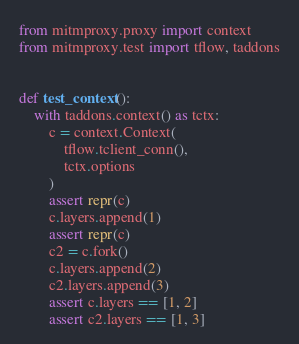<code> <loc_0><loc_0><loc_500><loc_500><_Python_>from mitmproxy.proxy import context
from mitmproxy.test import tflow, taddons


def test_context():
    with taddons.context() as tctx:
        c = context.Context(
            tflow.tclient_conn(),
            tctx.options
        )
        assert repr(c)
        c.layers.append(1)
        assert repr(c)
        c2 = c.fork()
        c.layers.append(2)
        c2.layers.append(3)
        assert c.layers == [1, 2]
        assert c2.layers == [1, 3]
</code> 